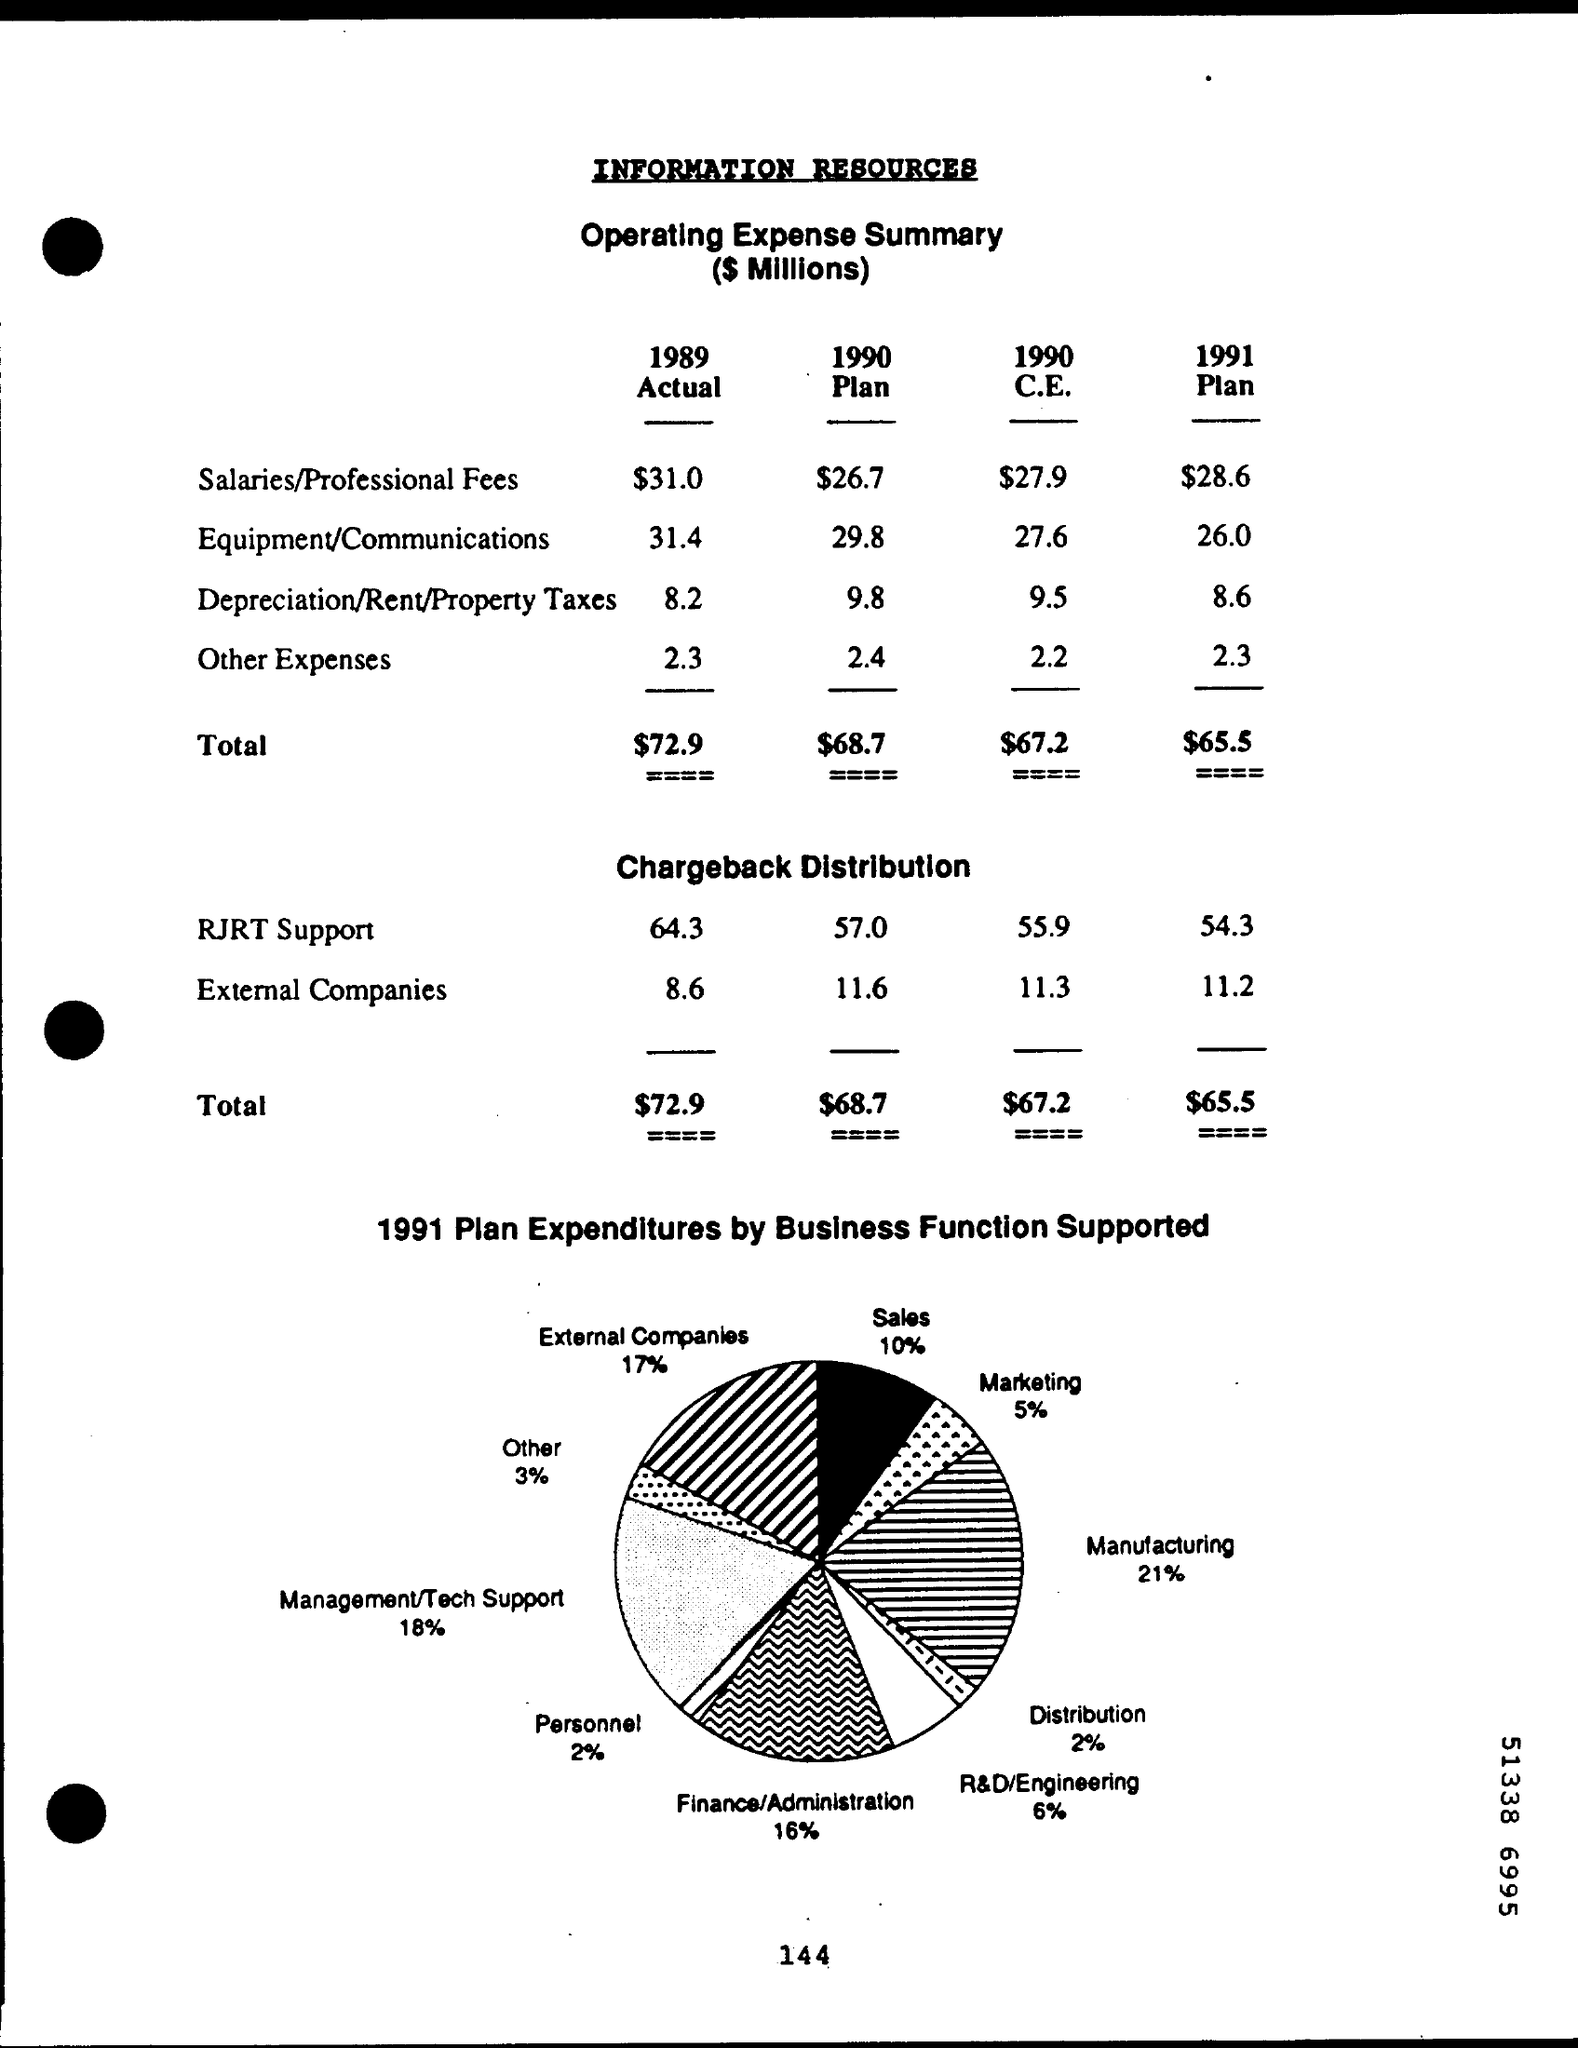According to 1991 plan expenditures by business function supported how much is the % of sales
Give a very brief answer. 10%. What is the actual other expenses for the year 1989
Your answer should be very brief. 2.3. What is the actual total  for the year 1989?
Ensure brevity in your answer.  $72.9. What is the total of the plan for the year 1990
Provide a short and direct response. $68.7. What is the total of c.e for the year 1990
Give a very brief answer. $67.2. What is the total plan for the year 1991
Ensure brevity in your answer.  $65.5. According to 1991 plan expenditures by business function supported how much is the % of marketing
Your answer should be compact. 5%. According to 1991 plan expenditures by business function supported how much is the % of distribution
Your response must be concise. 2%. According to 1991 plan expenditures by business function supported how much is the % of manufacturing
Provide a short and direct response. 21%. According to 1991 plan expenditures by business function supported how much is the % of  other
Keep it short and to the point. 3%. 